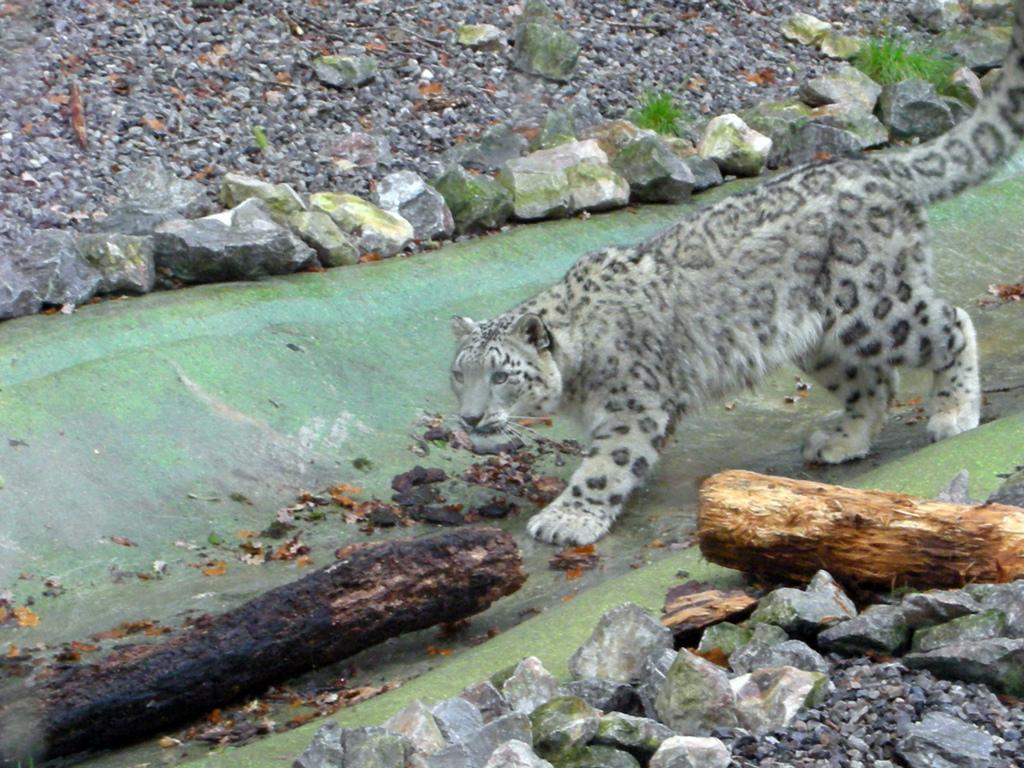Describe this image in one or two sentences. Here I can see a cheetah is walking on the ground. At the bottom of this image there are some stones and sticks. On the top also I can see the stones. 